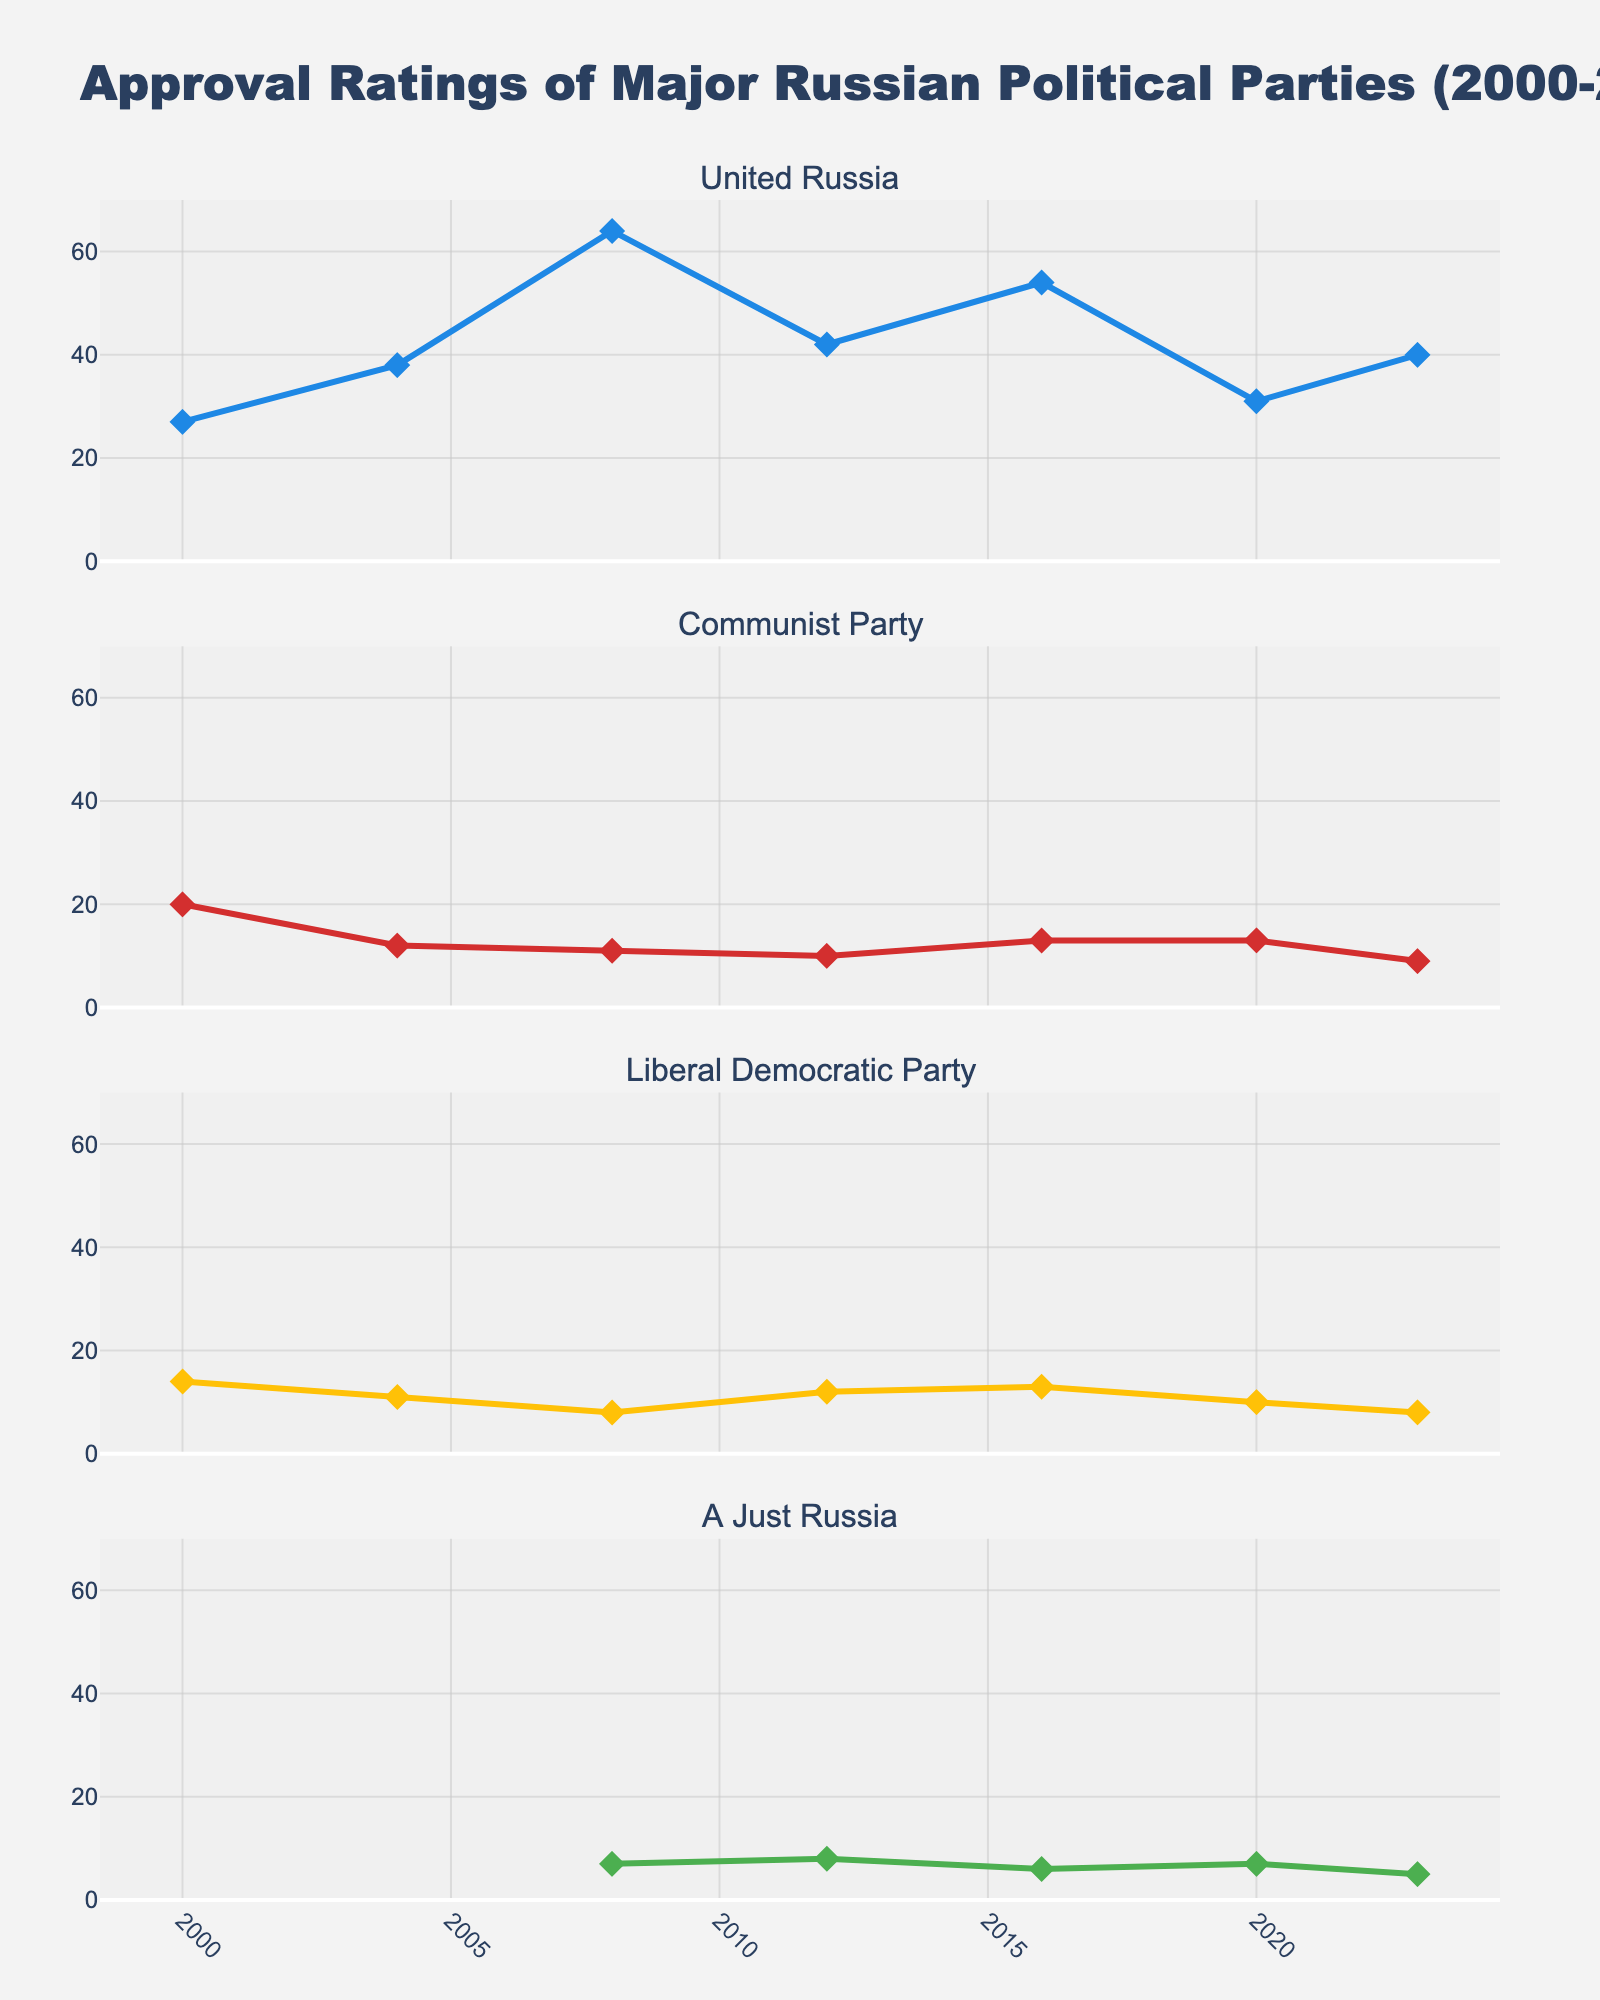What is the approval rating of United Russia in 2008? Look at the subplot for United Russia and find the data point corresponding to 2008. The approval rating is 64%.
Answer: 64% How did the approval rating of the Communist Party change from 2008 to 2023? Compare the approval rating of the Communist Party in 2008 (11%) to that in 2023 (9%). The approval dropped by 2 percentage points.
Answer: Decreased by 2 percentage points Which party had the highest approval rating in 2012? For the year 2012, compare the approval ratings across all four parties (United Russia 42%, Communist Party 10%, Liberal Democratic Party 12%, A Just Russia 8%). United Russia had the highest approval rating.
Answer: United Russia What is the average approval rating of the Liberal Democratic Party from 2008 to 2023? Sum the approval ratings of the Liberal Democratic Party from 2008 to 2023 (8 + 12 + 13 + 10 + 8) and then divide by the number of data points (5). The average is (8 + 12 + 13 + 10 + 8) / 5 = 10.2%.
Answer: 10.2% During which years was the approval rating of A Just Russia below 10%? Check the approval ratings of A Just Russia for all the years. It was below 10% in 2008 (7%), 2016 (6%), 2020 (7%), and 2023 (5%).
Answer: 2008, 2016, 2020, 2023 Did any party have an approval rating greater than 50% in 2016? Look at the approval ratings for all parties in 2016 (United Russia 54%, Communist Party 13%, Liberal Democratic Party 13%, A Just Russia 6%). United Russia had an approval rating greater than 50%.
Answer: Yes, United Russia What is the difference in approval ratings between United Russia and the Communist Party in 2023? Find the approval ratings for United Russia (40%) and the Communist Party (9%) in 2023 and subtract the latter from the former. The difference is 40% - 9% = 31%.
Answer: 31% Which party experienced the largest decline in approval rating between any two consecutive years? Check the approval ratings of all parties across all years. United Russia experienced the largest decline from 2008 (64%) to 2012 (42%), a drop of 22 percentage points.
Answer: United Russia How many years did the approval rating of the Liberal Democratic Party remain constant or increase? Review the approval ratings across all years and check the trend. Approval ratings: 2000 (14%), 2004 (11%), 2008 (8%), 2012 (12%), 2016 (13%), 2020 (10%), 2023 (8%). It decreased from 2000 to 2008, increased from 2008 to 2012 and 2012 to 2016, and decreased from 2016 to 2023. Three periods show either constant or increasing: 2000-2008, 2008-2012, 2012-2016.
Answer: 3 years 